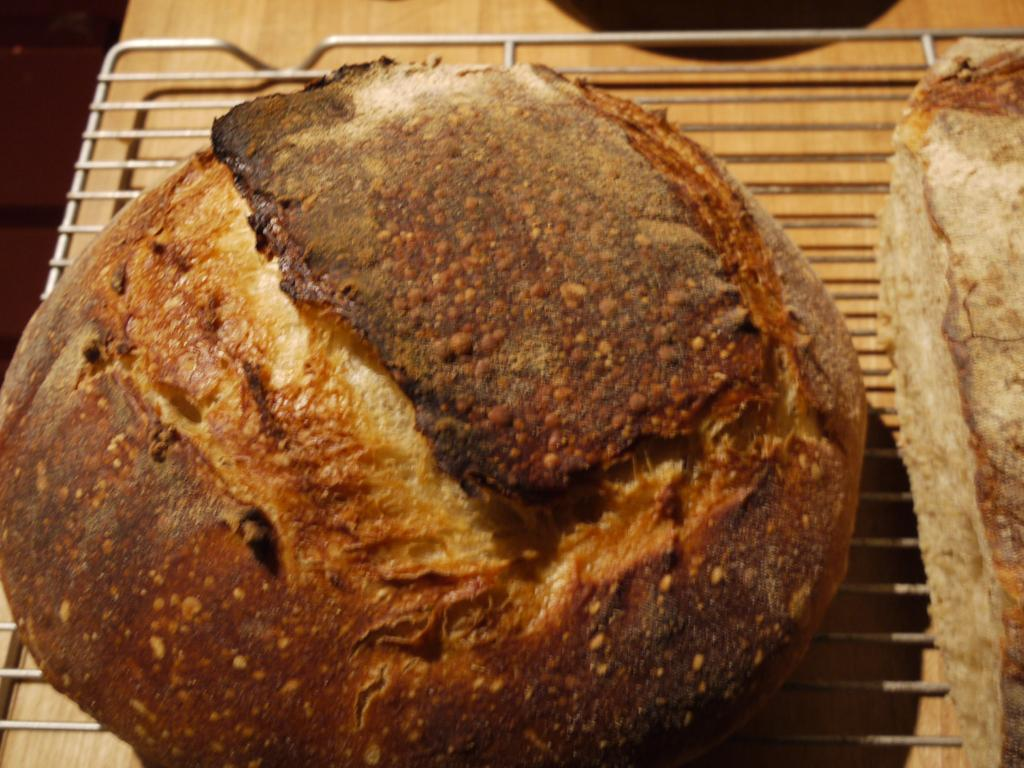What type of table is in the image? There is a cream-colored table in the image. What is on top of the table? There is a metal grill on the table. What is being cooked on the grill? There are two pieces of bread on the grill. What colors can be seen on the bread? The bread is cream, brown, and black in color. How many books are stacked on the goose in the image? There is no goose or books present in the image. 